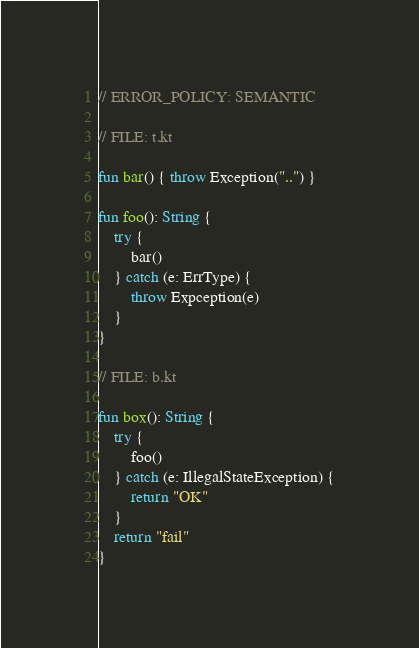Convert code to text. <code><loc_0><loc_0><loc_500><loc_500><_Kotlin_>// ERROR_POLICY: SEMANTIC

// FILE: t.kt

fun bar() { throw Exception("..") }

fun foo(): String {
    try {
        bar()
    } catch (e: ErrType) {
        throw Expception(e)
    }
}

// FILE: b.kt

fun box(): String {
    try {
        foo()
    } catch (e: IllegalStateException) {
        return "OK"
    }
    return "fail"
}</code> 